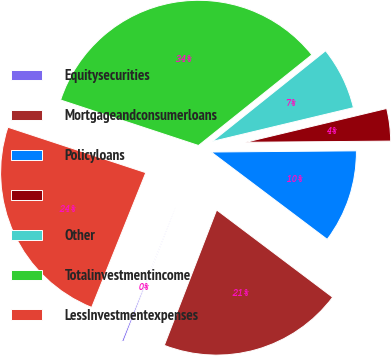Convert chart. <chart><loc_0><loc_0><loc_500><loc_500><pie_chart><fcel>Equitysecurities<fcel>Mortgageandconsumerloans<fcel>Policyloans<fcel>Unnamed: 3<fcel>Other<fcel>Totalinvestmentincome<fcel>LessInvestmentexpenses<nl><fcel>0.21%<fcel>20.6%<fcel>10.4%<fcel>3.61%<fcel>7.0%<fcel>34.19%<fcel>23.99%<nl></chart> 